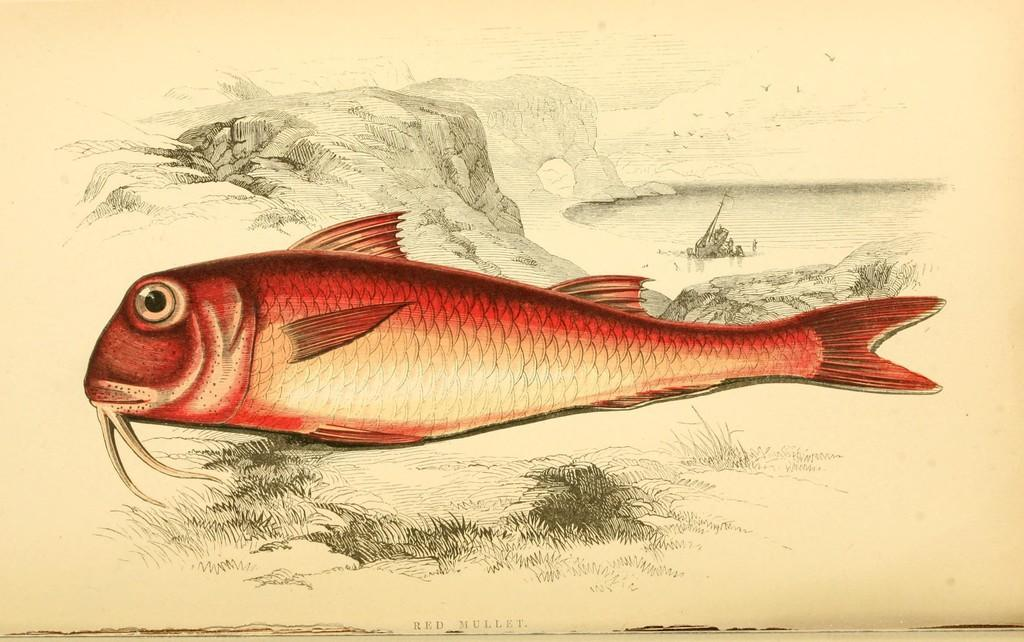What is the main subject of the picture? The main subject of the picture is a fish. What are some features of the fish? The fish has fins, eyes, a tail, and a mouth. What can be seen in the background of the image? There is grass and rocks in the backdrop of the image. What type of appliance is causing the fish pain in the image? There is no appliance present in the image, and the fish is not experiencing any pain. 